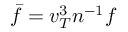<formula> <loc_0><loc_0><loc_500><loc_500>\bar { f } = v _ { T } ^ { 3 } n ^ { - 1 } f</formula> 